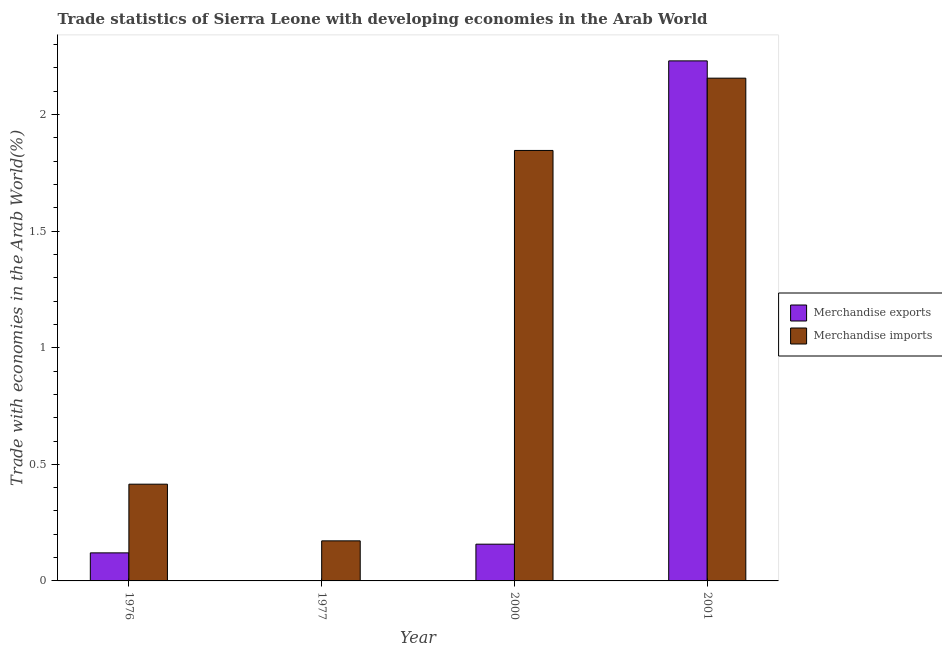How many different coloured bars are there?
Provide a succinct answer. 2. Are the number of bars per tick equal to the number of legend labels?
Your answer should be very brief. Yes. Are the number of bars on each tick of the X-axis equal?
Ensure brevity in your answer.  Yes. How many bars are there on the 4th tick from the right?
Provide a short and direct response. 2. What is the label of the 1st group of bars from the left?
Give a very brief answer. 1976. What is the merchandise exports in 2000?
Your answer should be compact. 0.16. Across all years, what is the maximum merchandise imports?
Make the answer very short. 2.16. Across all years, what is the minimum merchandise exports?
Ensure brevity in your answer.  0. In which year was the merchandise exports maximum?
Your response must be concise. 2001. In which year was the merchandise imports minimum?
Give a very brief answer. 1977. What is the total merchandise imports in the graph?
Keep it short and to the point. 4.59. What is the difference between the merchandise imports in 1977 and that in 2000?
Your response must be concise. -1.67. What is the difference between the merchandise imports in 1976 and the merchandise exports in 2001?
Your answer should be very brief. -1.74. What is the average merchandise imports per year?
Your response must be concise. 1.15. What is the ratio of the merchandise exports in 1976 to that in 2000?
Your answer should be very brief. 0.76. Is the difference between the merchandise imports in 1976 and 2001 greater than the difference between the merchandise exports in 1976 and 2001?
Give a very brief answer. No. What is the difference between the highest and the second highest merchandise exports?
Keep it short and to the point. 2.07. What is the difference between the highest and the lowest merchandise exports?
Provide a succinct answer. 2.23. In how many years, is the merchandise exports greater than the average merchandise exports taken over all years?
Your answer should be very brief. 1. How many bars are there?
Offer a very short reply. 8. Where does the legend appear in the graph?
Provide a succinct answer. Center right. What is the title of the graph?
Make the answer very short. Trade statistics of Sierra Leone with developing economies in the Arab World. What is the label or title of the X-axis?
Offer a terse response. Year. What is the label or title of the Y-axis?
Provide a succinct answer. Trade with economies in the Arab World(%). What is the Trade with economies in the Arab World(%) in Merchandise exports in 1976?
Make the answer very short. 0.12. What is the Trade with economies in the Arab World(%) of Merchandise imports in 1976?
Offer a terse response. 0.41. What is the Trade with economies in the Arab World(%) of Merchandise exports in 1977?
Ensure brevity in your answer.  0. What is the Trade with economies in the Arab World(%) in Merchandise imports in 1977?
Ensure brevity in your answer.  0.17. What is the Trade with economies in the Arab World(%) of Merchandise exports in 2000?
Your response must be concise. 0.16. What is the Trade with economies in the Arab World(%) in Merchandise imports in 2000?
Offer a very short reply. 1.85. What is the Trade with economies in the Arab World(%) of Merchandise exports in 2001?
Provide a succinct answer. 2.23. What is the Trade with economies in the Arab World(%) in Merchandise imports in 2001?
Make the answer very short. 2.16. Across all years, what is the maximum Trade with economies in the Arab World(%) of Merchandise exports?
Your response must be concise. 2.23. Across all years, what is the maximum Trade with economies in the Arab World(%) of Merchandise imports?
Ensure brevity in your answer.  2.16. Across all years, what is the minimum Trade with economies in the Arab World(%) in Merchandise exports?
Offer a terse response. 0. Across all years, what is the minimum Trade with economies in the Arab World(%) of Merchandise imports?
Give a very brief answer. 0.17. What is the total Trade with economies in the Arab World(%) of Merchandise exports in the graph?
Offer a terse response. 2.51. What is the total Trade with economies in the Arab World(%) of Merchandise imports in the graph?
Offer a terse response. 4.59. What is the difference between the Trade with economies in the Arab World(%) of Merchandise exports in 1976 and that in 1977?
Offer a very short reply. 0.12. What is the difference between the Trade with economies in the Arab World(%) of Merchandise imports in 1976 and that in 1977?
Provide a succinct answer. 0.24. What is the difference between the Trade with economies in the Arab World(%) in Merchandise exports in 1976 and that in 2000?
Keep it short and to the point. -0.04. What is the difference between the Trade with economies in the Arab World(%) in Merchandise imports in 1976 and that in 2000?
Your response must be concise. -1.43. What is the difference between the Trade with economies in the Arab World(%) in Merchandise exports in 1976 and that in 2001?
Provide a succinct answer. -2.11. What is the difference between the Trade with economies in the Arab World(%) in Merchandise imports in 1976 and that in 2001?
Ensure brevity in your answer.  -1.74. What is the difference between the Trade with economies in the Arab World(%) in Merchandise exports in 1977 and that in 2000?
Your answer should be very brief. -0.16. What is the difference between the Trade with economies in the Arab World(%) of Merchandise imports in 1977 and that in 2000?
Give a very brief answer. -1.67. What is the difference between the Trade with economies in the Arab World(%) of Merchandise exports in 1977 and that in 2001?
Your response must be concise. -2.23. What is the difference between the Trade with economies in the Arab World(%) of Merchandise imports in 1977 and that in 2001?
Offer a very short reply. -1.98. What is the difference between the Trade with economies in the Arab World(%) in Merchandise exports in 2000 and that in 2001?
Give a very brief answer. -2.07. What is the difference between the Trade with economies in the Arab World(%) of Merchandise imports in 2000 and that in 2001?
Offer a very short reply. -0.31. What is the difference between the Trade with economies in the Arab World(%) in Merchandise exports in 1976 and the Trade with economies in the Arab World(%) in Merchandise imports in 1977?
Make the answer very short. -0.05. What is the difference between the Trade with economies in the Arab World(%) in Merchandise exports in 1976 and the Trade with economies in the Arab World(%) in Merchandise imports in 2000?
Provide a succinct answer. -1.73. What is the difference between the Trade with economies in the Arab World(%) of Merchandise exports in 1976 and the Trade with economies in the Arab World(%) of Merchandise imports in 2001?
Keep it short and to the point. -2.04. What is the difference between the Trade with economies in the Arab World(%) of Merchandise exports in 1977 and the Trade with economies in the Arab World(%) of Merchandise imports in 2000?
Your answer should be compact. -1.85. What is the difference between the Trade with economies in the Arab World(%) in Merchandise exports in 1977 and the Trade with economies in the Arab World(%) in Merchandise imports in 2001?
Offer a terse response. -2.16. What is the difference between the Trade with economies in the Arab World(%) of Merchandise exports in 2000 and the Trade with economies in the Arab World(%) of Merchandise imports in 2001?
Make the answer very short. -2. What is the average Trade with economies in the Arab World(%) of Merchandise exports per year?
Give a very brief answer. 0.63. What is the average Trade with economies in the Arab World(%) of Merchandise imports per year?
Provide a succinct answer. 1.15. In the year 1976, what is the difference between the Trade with economies in the Arab World(%) in Merchandise exports and Trade with economies in the Arab World(%) in Merchandise imports?
Your answer should be very brief. -0.29. In the year 1977, what is the difference between the Trade with economies in the Arab World(%) of Merchandise exports and Trade with economies in the Arab World(%) of Merchandise imports?
Your answer should be compact. -0.17. In the year 2000, what is the difference between the Trade with economies in the Arab World(%) of Merchandise exports and Trade with economies in the Arab World(%) of Merchandise imports?
Provide a short and direct response. -1.69. In the year 2001, what is the difference between the Trade with economies in the Arab World(%) of Merchandise exports and Trade with economies in the Arab World(%) of Merchandise imports?
Provide a succinct answer. 0.07. What is the ratio of the Trade with economies in the Arab World(%) of Merchandise exports in 1976 to that in 1977?
Offer a very short reply. 149.48. What is the ratio of the Trade with economies in the Arab World(%) of Merchandise imports in 1976 to that in 1977?
Your answer should be compact. 2.41. What is the ratio of the Trade with economies in the Arab World(%) of Merchandise exports in 1976 to that in 2000?
Give a very brief answer. 0.76. What is the ratio of the Trade with economies in the Arab World(%) in Merchandise imports in 1976 to that in 2000?
Ensure brevity in your answer.  0.22. What is the ratio of the Trade with economies in the Arab World(%) of Merchandise exports in 1976 to that in 2001?
Your answer should be compact. 0.05. What is the ratio of the Trade with economies in the Arab World(%) of Merchandise imports in 1976 to that in 2001?
Offer a terse response. 0.19. What is the ratio of the Trade with economies in the Arab World(%) of Merchandise exports in 1977 to that in 2000?
Make the answer very short. 0.01. What is the ratio of the Trade with economies in the Arab World(%) in Merchandise imports in 1977 to that in 2000?
Keep it short and to the point. 0.09. What is the ratio of the Trade with economies in the Arab World(%) in Merchandise exports in 1977 to that in 2001?
Provide a succinct answer. 0. What is the ratio of the Trade with economies in the Arab World(%) in Merchandise imports in 1977 to that in 2001?
Your answer should be compact. 0.08. What is the ratio of the Trade with economies in the Arab World(%) in Merchandise exports in 2000 to that in 2001?
Provide a short and direct response. 0.07. What is the ratio of the Trade with economies in the Arab World(%) in Merchandise imports in 2000 to that in 2001?
Your response must be concise. 0.86. What is the difference between the highest and the second highest Trade with economies in the Arab World(%) of Merchandise exports?
Your response must be concise. 2.07. What is the difference between the highest and the second highest Trade with economies in the Arab World(%) of Merchandise imports?
Your answer should be very brief. 0.31. What is the difference between the highest and the lowest Trade with economies in the Arab World(%) in Merchandise exports?
Provide a succinct answer. 2.23. What is the difference between the highest and the lowest Trade with economies in the Arab World(%) in Merchandise imports?
Your answer should be compact. 1.98. 